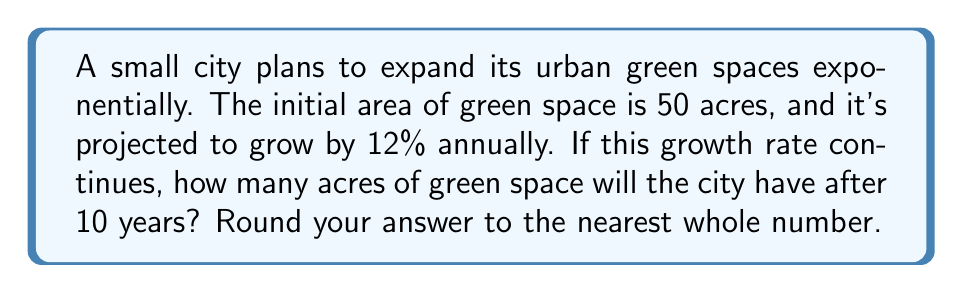Can you answer this question? Let's approach this step-by-step using an exponential function:

1) The general form of an exponential growth function is:
   $$A(t) = A_0 \cdot (1 + r)^t$$
   Where:
   $A(t)$ is the area after time $t$
   $A_0$ is the initial area
   $r$ is the growth rate (as a decimal)
   $t$ is the time in years

2) We know:
   $A_0 = 50$ acres (initial area)
   $r = 0.12$ (12% growth rate)
   $t = 10$ years

3) Let's substitute these values into our equation:
   $$A(10) = 50 \cdot (1 + 0.12)^{10}$$

4) Simplify inside the parentheses:
   $$A(10) = 50 \cdot (1.12)^{10}$$

5) Use a calculator to evaluate $(1.12)^{10}$:
   $$A(10) = 50 \cdot 3.1058$$

6) Multiply:
   $$A(10) = 155.29$$

7) Rounding to the nearest whole number:
   $$A(10) \approx 155$$ acres
Answer: 155 acres 